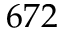<formula> <loc_0><loc_0><loc_500><loc_500>6 7 2</formula> 